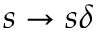<formula> <loc_0><loc_0><loc_500><loc_500>s \to s \delta</formula> 